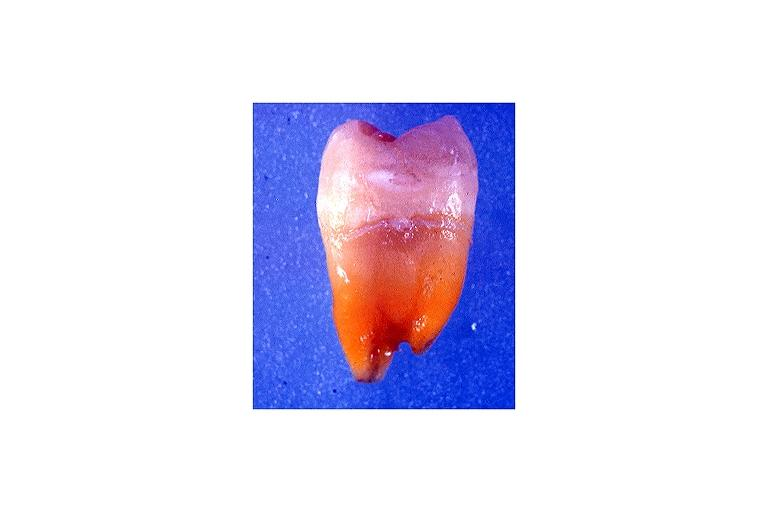where is this?
Answer the question using a single word or phrase. Oral 